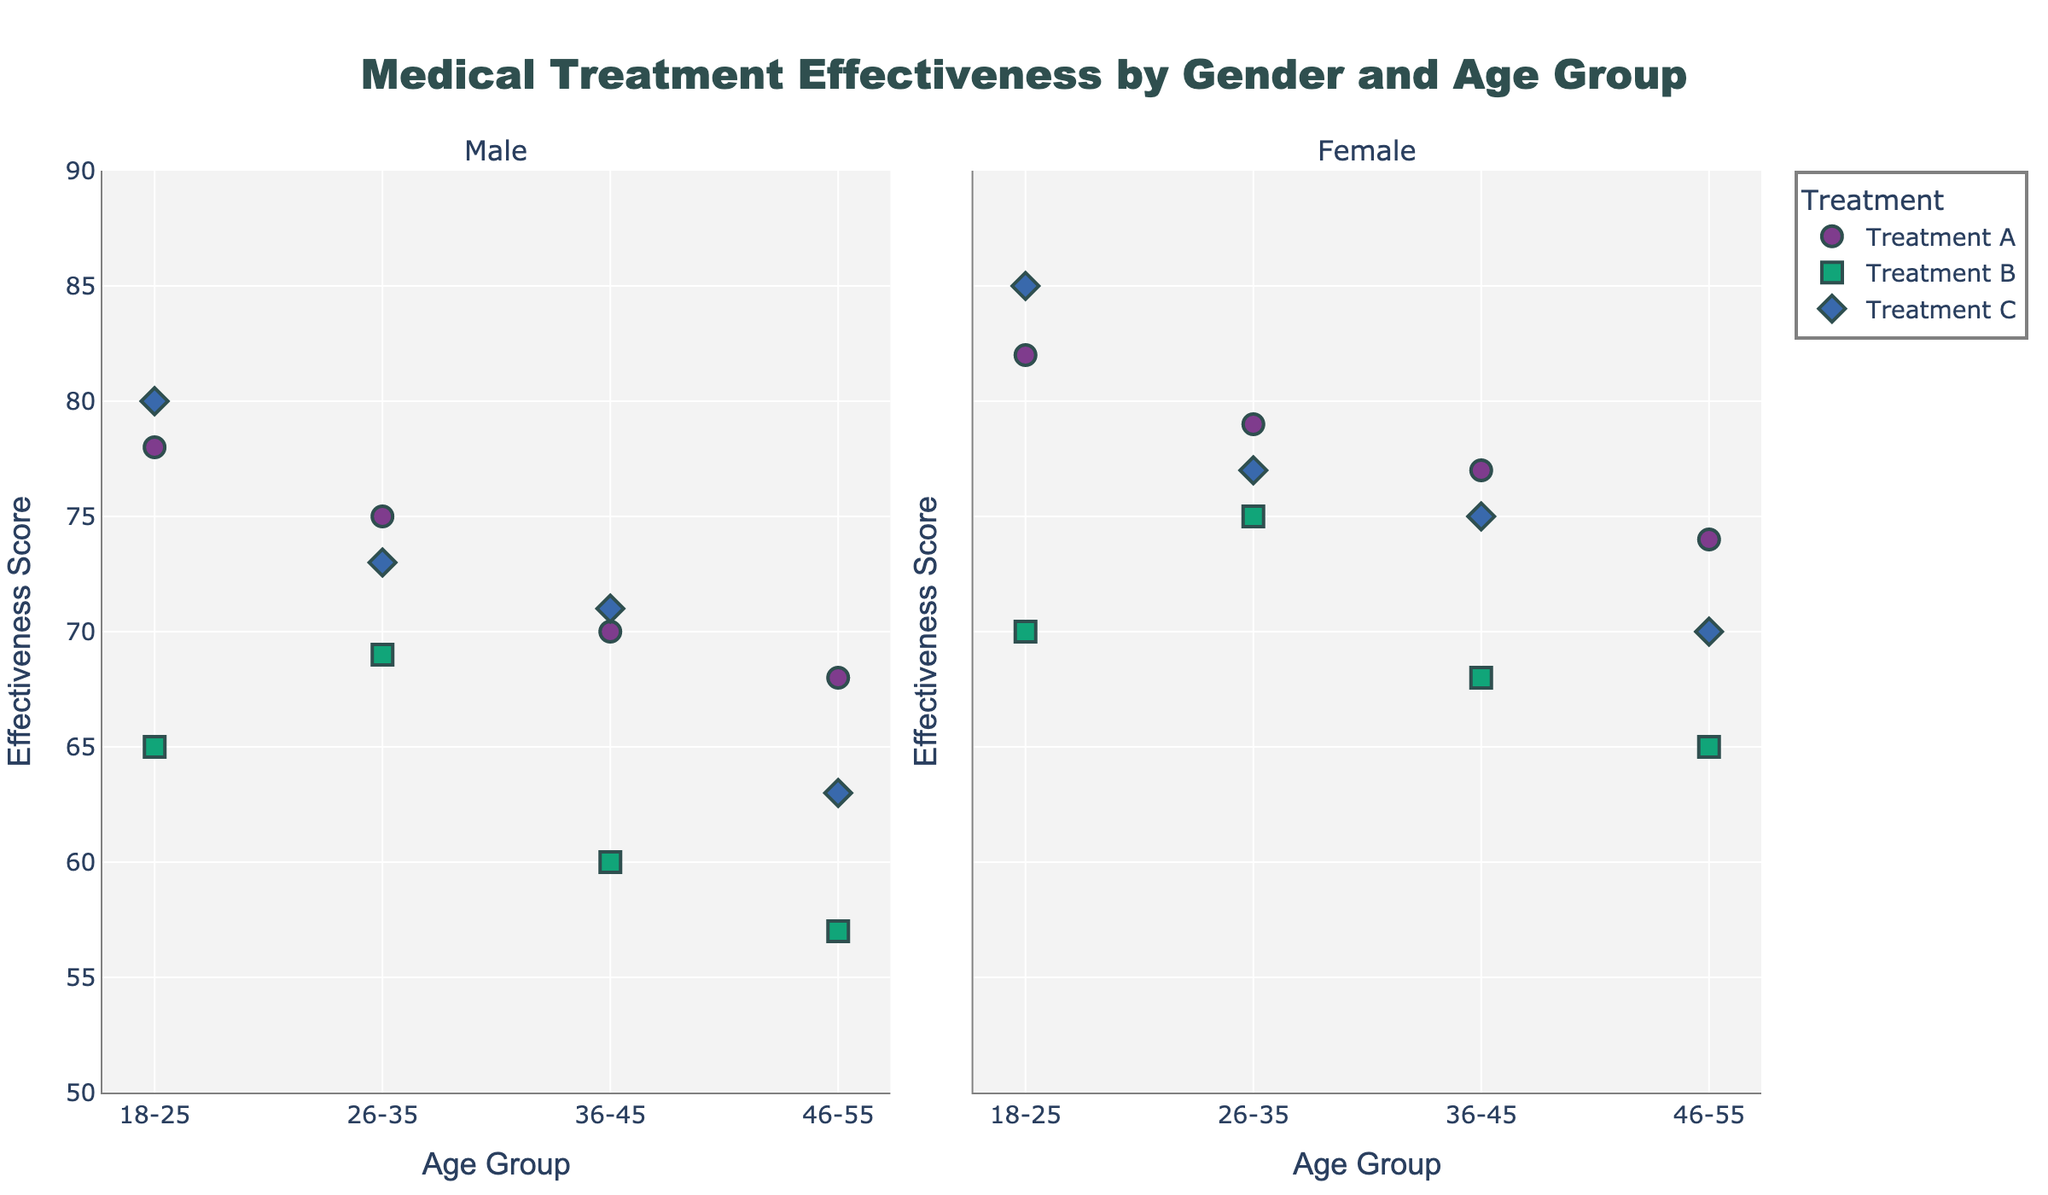What is the title of the figure? The title of the figure is usually found at the top center of the plot. It provides a brief description of what the figure is about.
Answer: Medical Treatment Effectiveness by Gender and Age Group How many age groups are represented in the plot? The age groups are represented on the x-axis. By counting the unique categories on the x-axis, we can determine the number of age groups.
Answer: 4 Which treatment has the highest effectiveness score for females aged 18-25? To find the highest effectiveness score for females aged 18-25, look at the data points in the Female subplot that correspond to the 18-25 age group and identify the highest score among Treatment A, B, and C.
Answer: Treatment C Is there a gender difference in effectiveness scores for Treatment B in the 46-55 age group? Compare the effectiveness scores for males and females within the 46-55 age group for Treatment B. Look for the data points in each subplot and compare their values.
Answer: Yes, females have a higher score For Treatment A, which gender shows a more consistent effectiveness score across age groups? Consistency can be evaluated by observing the variance in the effectiveness scores across the different age groups. Compare the spread of scores between the Male and Female subplots for Treatment A.
Answer: Female What is the lowest effectiveness score recorded and for which treatment and age group is it? Examine all the data points on the plot and identify the one with the lowest y-value (effectiveness score). Note its corresponding treatment and age group.
Answer: 57; Treatment B, Male, 46-55 Comparing treatments A and C, which treatment has a higher average effectiveness score across all age groups and genders? Calculate the average effectiveness score for both treatments by summing the scores of each and dividing by the number of data points (8 per treatment). Compare the averages to determine which is higher.
Answer: Treatment A In the 36-45 age group, how do the effectiveness scores for males compare to those for females across all treatments? For each treatment in the 36-45 age group, compare the effectiveness scores between males and females by checking the corresponding data points in both subplots.
Answer: Females consistently have higher scores Which treatment shows the largest gender disparity in effectiveness score within any specific age group? Identify the treatment with the largest difference between male and female effectiveness scores within the same age group by comparing the data points in both subplots.
Answer: Treatment B in the 46-55 age group 